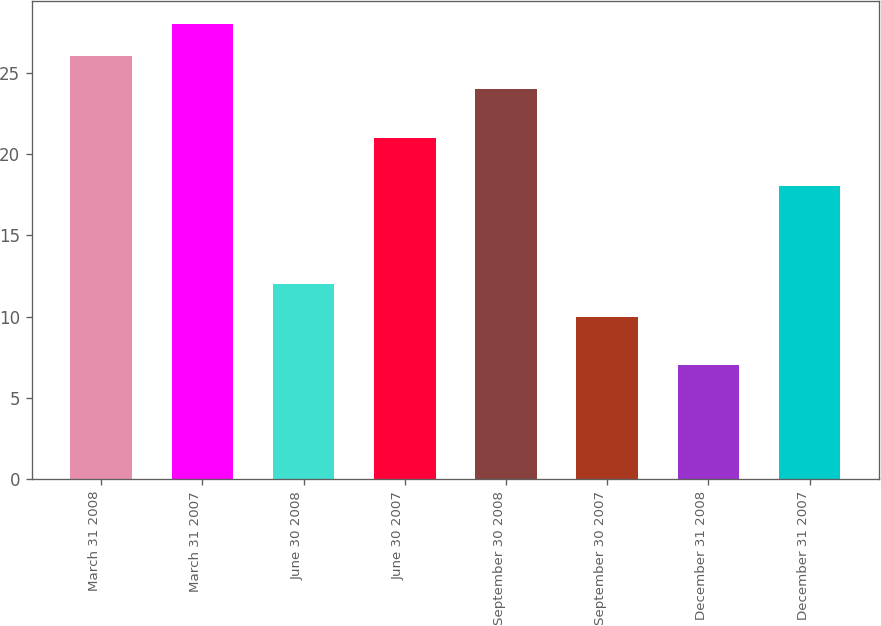<chart> <loc_0><loc_0><loc_500><loc_500><bar_chart><fcel>March 31 2008<fcel>March 31 2007<fcel>June 30 2008<fcel>June 30 2007<fcel>September 30 2008<fcel>September 30 2007<fcel>December 31 2008<fcel>December 31 2007<nl><fcel>26<fcel>28<fcel>12<fcel>21<fcel>24<fcel>10<fcel>7<fcel>18<nl></chart> 